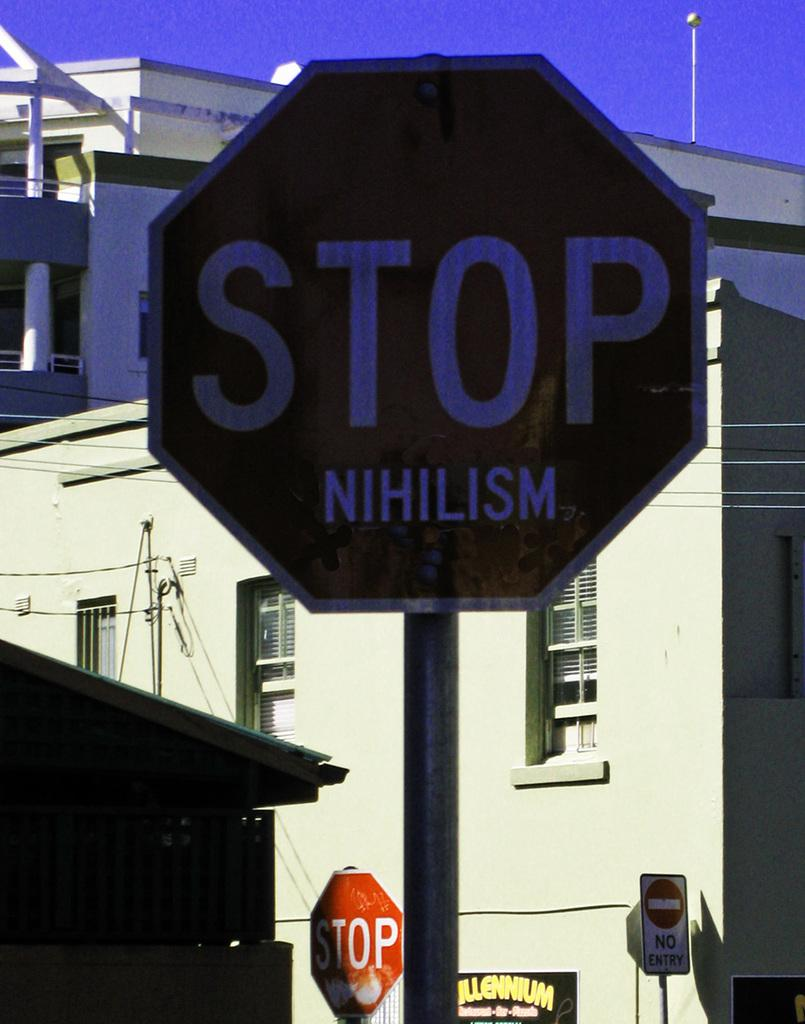<image>
Offer a succinct explanation of the picture presented. The white letters on the red sign say stop nihilism. 